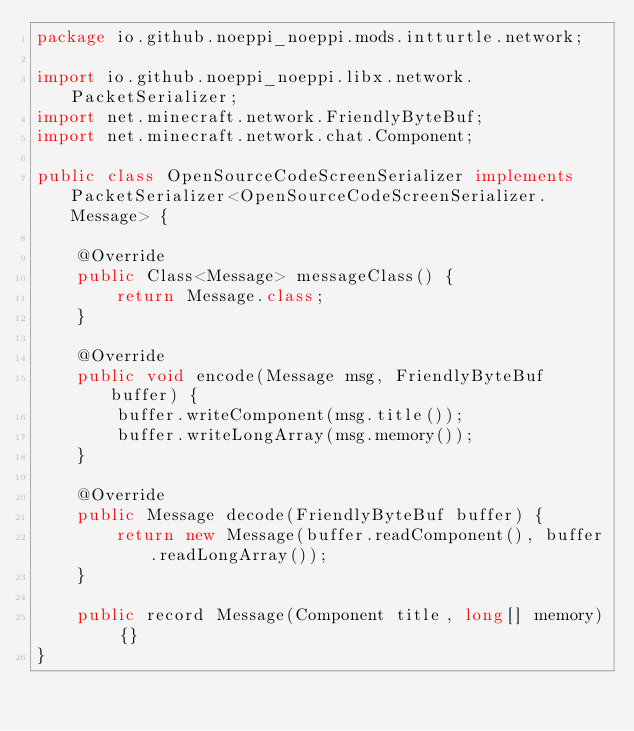Convert code to text. <code><loc_0><loc_0><loc_500><loc_500><_Java_>package io.github.noeppi_noeppi.mods.intturtle.network;

import io.github.noeppi_noeppi.libx.network.PacketSerializer;
import net.minecraft.network.FriendlyByteBuf;
import net.minecraft.network.chat.Component;

public class OpenSourceCodeScreenSerializer implements PacketSerializer<OpenSourceCodeScreenSerializer.Message> {

    @Override
    public Class<Message> messageClass() {
        return Message.class;
    }

    @Override
    public void encode(Message msg, FriendlyByteBuf buffer) {
        buffer.writeComponent(msg.title());
        buffer.writeLongArray(msg.memory());
    }

    @Override
    public Message decode(FriendlyByteBuf buffer) {
        return new Message(buffer.readComponent(), buffer.readLongArray());
    }

    public record Message(Component title, long[] memory) {}
}
</code> 